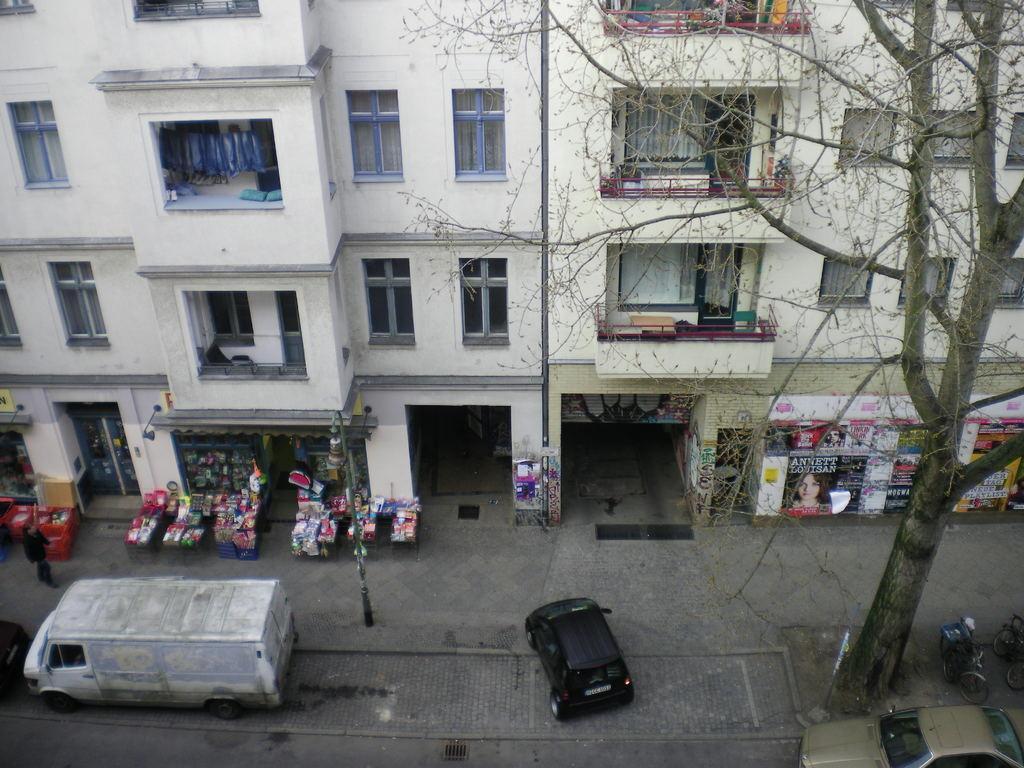How would you summarize this image in a sentence or two? This image is clicked from a top view. At the bottom there vehicles moving on the road. Beside the road there is a walkway. There are poles and a tree on the walkway. Beside the walkway there are buildings. There are baskets on the walkway. There are posters and boards sticked on the walls of the building. 